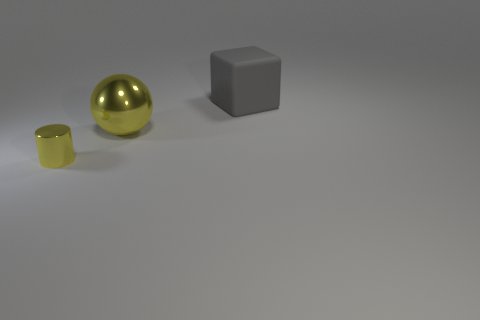Is there any other thing that has the same material as the large cube?
Make the answer very short. No. Is the number of metal things that are on the left side of the yellow metallic cylinder greater than the number of metallic spheres?
Make the answer very short. No. Is there any other thing that is the same color as the large matte cube?
Your answer should be very brief. No. The metal object left of the yellow object behind the shiny cylinder is what shape?
Your answer should be very brief. Cylinder. Are there more large gray rubber things than large purple things?
Your response must be concise. Yes. How many things are both to the right of the small yellow thing and to the left of the large gray object?
Offer a terse response. 1. There is a yellow object that is behind the metallic cylinder; how many things are left of it?
Offer a terse response. 1. How many things are things behind the metal cylinder or yellow metal objects that are in front of the big yellow metallic object?
Your response must be concise. 3. What number of things are metal things to the left of the big shiny thing or large yellow blocks?
Make the answer very short. 1. The big yellow thing that is made of the same material as the cylinder is what shape?
Ensure brevity in your answer.  Sphere. 